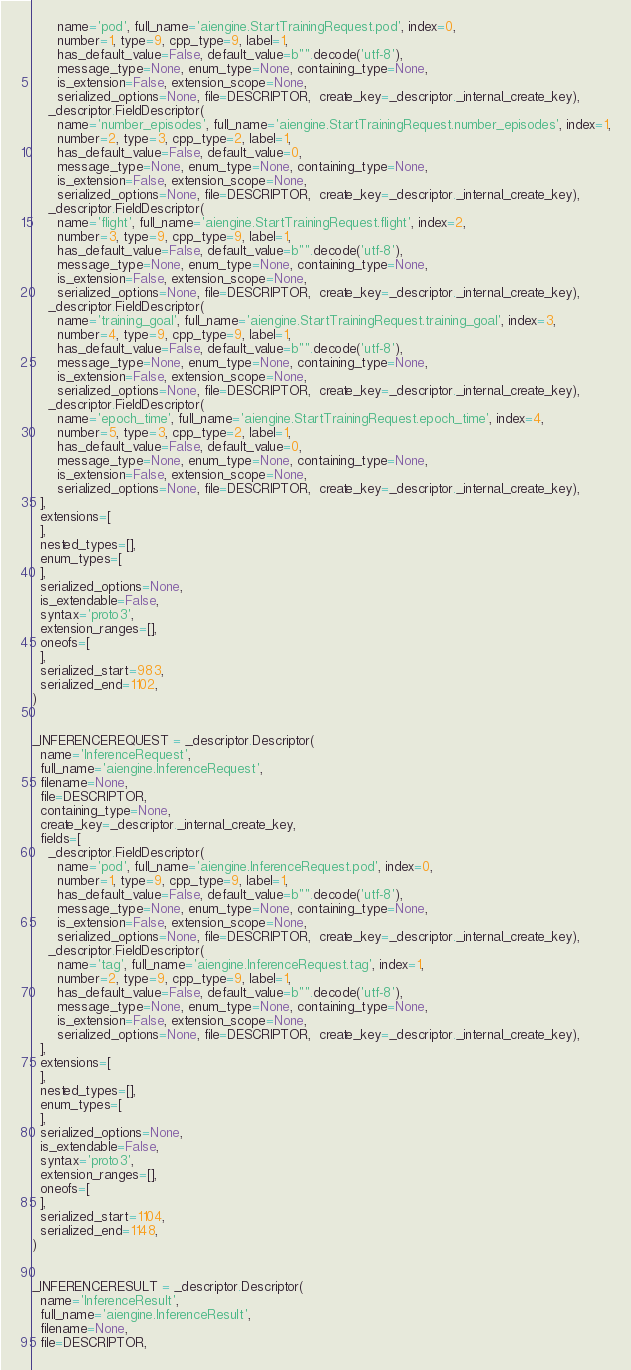<code> <loc_0><loc_0><loc_500><loc_500><_Python_>      name='pod', full_name='aiengine.StartTrainingRequest.pod', index=0,
      number=1, type=9, cpp_type=9, label=1,
      has_default_value=False, default_value=b"".decode('utf-8'),
      message_type=None, enum_type=None, containing_type=None,
      is_extension=False, extension_scope=None,
      serialized_options=None, file=DESCRIPTOR,  create_key=_descriptor._internal_create_key),
    _descriptor.FieldDescriptor(
      name='number_episodes', full_name='aiengine.StartTrainingRequest.number_episodes', index=1,
      number=2, type=3, cpp_type=2, label=1,
      has_default_value=False, default_value=0,
      message_type=None, enum_type=None, containing_type=None,
      is_extension=False, extension_scope=None,
      serialized_options=None, file=DESCRIPTOR,  create_key=_descriptor._internal_create_key),
    _descriptor.FieldDescriptor(
      name='flight', full_name='aiengine.StartTrainingRequest.flight', index=2,
      number=3, type=9, cpp_type=9, label=1,
      has_default_value=False, default_value=b"".decode('utf-8'),
      message_type=None, enum_type=None, containing_type=None,
      is_extension=False, extension_scope=None,
      serialized_options=None, file=DESCRIPTOR,  create_key=_descriptor._internal_create_key),
    _descriptor.FieldDescriptor(
      name='training_goal', full_name='aiengine.StartTrainingRequest.training_goal', index=3,
      number=4, type=9, cpp_type=9, label=1,
      has_default_value=False, default_value=b"".decode('utf-8'),
      message_type=None, enum_type=None, containing_type=None,
      is_extension=False, extension_scope=None,
      serialized_options=None, file=DESCRIPTOR,  create_key=_descriptor._internal_create_key),
    _descriptor.FieldDescriptor(
      name='epoch_time', full_name='aiengine.StartTrainingRequest.epoch_time', index=4,
      number=5, type=3, cpp_type=2, label=1,
      has_default_value=False, default_value=0,
      message_type=None, enum_type=None, containing_type=None,
      is_extension=False, extension_scope=None,
      serialized_options=None, file=DESCRIPTOR,  create_key=_descriptor._internal_create_key),
  ],
  extensions=[
  ],
  nested_types=[],
  enum_types=[
  ],
  serialized_options=None,
  is_extendable=False,
  syntax='proto3',
  extension_ranges=[],
  oneofs=[
  ],
  serialized_start=983,
  serialized_end=1102,
)


_INFERENCEREQUEST = _descriptor.Descriptor(
  name='InferenceRequest',
  full_name='aiengine.InferenceRequest',
  filename=None,
  file=DESCRIPTOR,
  containing_type=None,
  create_key=_descriptor._internal_create_key,
  fields=[
    _descriptor.FieldDescriptor(
      name='pod', full_name='aiengine.InferenceRequest.pod', index=0,
      number=1, type=9, cpp_type=9, label=1,
      has_default_value=False, default_value=b"".decode('utf-8'),
      message_type=None, enum_type=None, containing_type=None,
      is_extension=False, extension_scope=None,
      serialized_options=None, file=DESCRIPTOR,  create_key=_descriptor._internal_create_key),
    _descriptor.FieldDescriptor(
      name='tag', full_name='aiengine.InferenceRequest.tag', index=1,
      number=2, type=9, cpp_type=9, label=1,
      has_default_value=False, default_value=b"".decode('utf-8'),
      message_type=None, enum_type=None, containing_type=None,
      is_extension=False, extension_scope=None,
      serialized_options=None, file=DESCRIPTOR,  create_key=_descriptor._internal_create_key),
  ],
  extensions=[
  ],
  nested_types=[],
  enum_types=[
  ],
  serialized_options=None,
  is_extendable=False,
  syntax='proto3',
  extension_ranges=[],
  oneofs=[
  ],
  serialized_start=1104,
  serialized_end=1148,
)


_INFERENCERESULT = _descriptor.Descriptor(
  name='InferenceResult',
  full_name='aiengine.InferenceResult',
  filename=None,
  file=DESCRIPTOR,</code> 